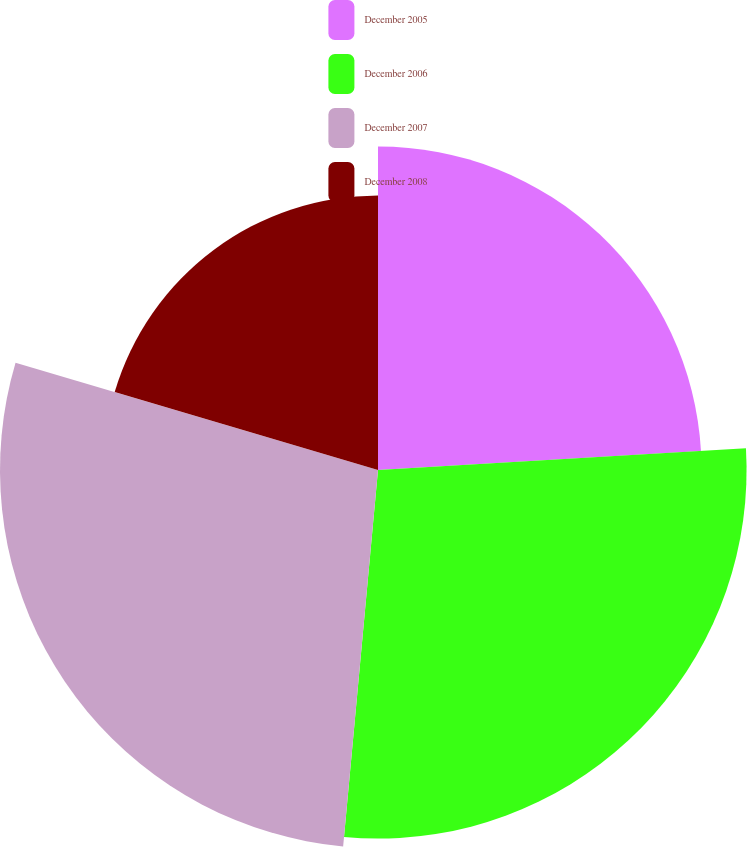<chart> <loc_0><loc_0><loc_500><loc_500><pie_chart><fcel>December 2005<fcel>December 2006<fcel>December 2007<fcel>December 2008<nl><fcel>24.06%<fcel>27.41%<fcel>28.11%<fcel>20.42%<nl></chart> 